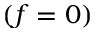<formula> <loc_0><loc_0><loc_500><loc_500>( f = 0 )</formula> 